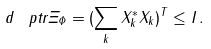Convert formula to latex. <formula><loc_0><loc_0><loc_500><loc_500>d \, \ p t r { \Xi _ { \Phi } } = ( \sum _ { k } X _ { k } ^ { * } X _ { k } ) ^ { T } \leq I \, .</formula> 